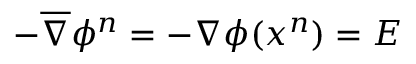Convert formula to latex. <formula><loc_0><loc_0><loc_500><loc_500>- \overline { \nabla } \phi ^ { n } = - \nabla \phi ( x ^ { n } ) = E</formula> 